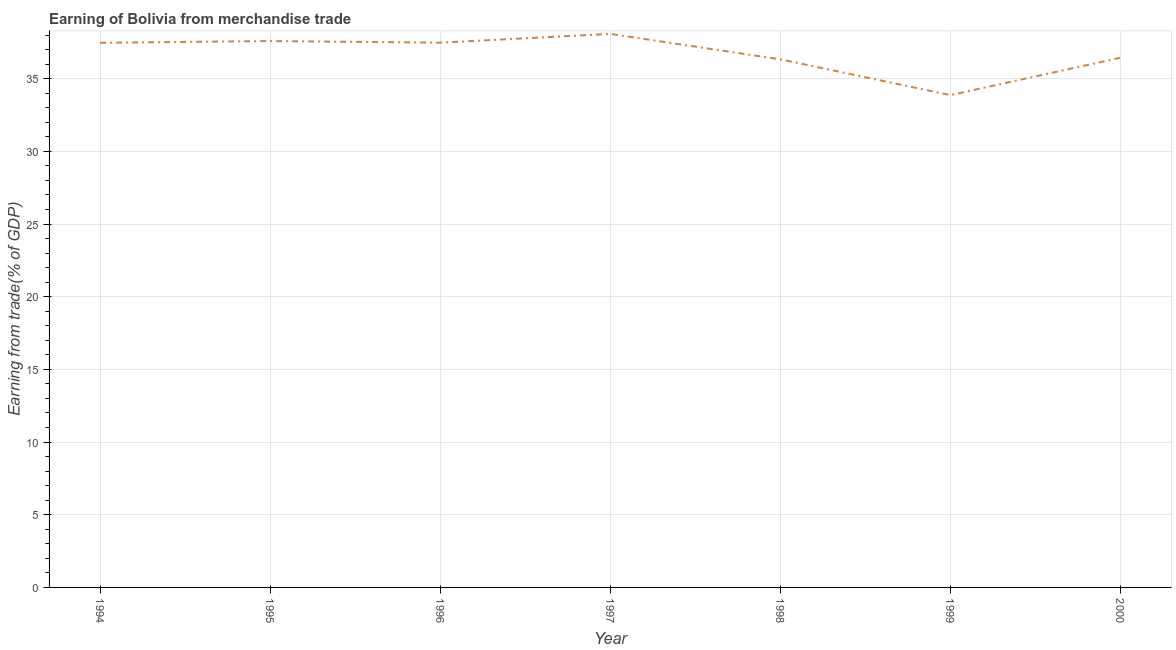What is the earning from merchandise trade in 1996?
Your answer should be very brief. 37.47. Across all years, what is the maximum earning from merchandise trade?
Your answer should be compact. 38.08. Across all years, what is the minimum earning from merchandise trade?
Provide a succinct answer. 33.87. In which year was the earning from merchandise trade maximum?
Your answer should be very brief. 1997. In which year was the earning from merchandise trade minimum?
Offer a terse response. 1999. What is the sum of the earning from merchandise trade?
Offer a terse response. 257.24. What is the difference between the earning from merchandise trade in 1995 and 1997?
Give a very brief answer. -0.49. What is the average earning from merchandise trade per year?
Your answer should be compact. 36.75. What is the median earning from merchandise trade?
Offer a terse response. 37.47. What is the ratio of the earning from merchandise trade in 1995 to that in 1996?
Your answer should be very brief. 1. Is the earning from merchandise trade in 1997 less than that in 2000?
Offer a very short reply. No. Is the difference between the earning from merchandise trade in 1994 and 1997 greater than the difference between any two years?
Offer a terse response. No. What is the difference between the highest and the second highest earning from merchandise trade?
Make the answer very short. 0.49. What is the difference between the highest and the lowest earning from merchandise trade?
Offer a terse response. 4.21. In how many years, is the earning from merchandise trade greater than the average earning from merchandise trade taken over all years?
Your answer should be very brief. 4. Does the graph contain grids?
Ensure brevity in your answer.  Yes. What is the title of the graph?
Your response must be concise. Earning of Bolivia from merchandise trade. What is the label or title of the X-axis?
Keep it short and to the point. Year. What is the label or title of the Y-axis?
Provide a succinct answer. Earning from trade(% of GDP). What is the Earning from trade(% of GDP) of 1994?
Your answer should be compact. 37.47. What is the Earning from trade(% of GDP) in 1995?
Make the answer very short. 37.59. What is the Earning from trade(% of GDP) of 1996?
Your answer should be very brief. 37.47. What is the Earning from trade(% of GDP) of 1997?
Give a very brief answer. 38.08. What is the Earning from trade(% of GDP) of 1998?
Your answer should be very brief. 36.33. What is the Earning from trade(% of GDP) of 1999?
Offer a very short reply. 33.87. What is the Earning from trade(% of GDP) in 2000?
Your response must be concise. 36.44. What is the difference between the Earning from trade(% of GDP) in 1994 and 1995?
Offer a terse response. -0.12. What is the difference between the Earning from trade(% of GDP) in 1994 and 1996?
Ensure brevity in your answer.  -0.01. What is the difference between the Earning from trade(% of GDP) in 1994 and 1997?
Offer a very short reply. -0.61. What is the difference between the Earning from trade(% of GDP) in 1994 and 1998?
Provide a succinct answer. 1.14. What is the difference between the Earning from trade(% of GDP) in 1994 and 1999?
Your response must be concise. 3.6. What is the difference between the Earning from trade(% of GDP) in 1994 and 2000?
Offer a very short reply. 1.03. What is the difference between the Earning from trade(% of GDP) in 1995 and 1996?
Your answer should be very brief. 0.11. What is the difference between the Earning from trade(% of GDP) in 1995 and 1997?
Your answer should be compact. -0.49. What is the difference between the Earning from trade(% of GDP) in 1995 and 1998?
Offer a very short reply. 1.26. What is the difference between the Earning from trade(% of GDP) in 1995 and 1999?
Offer a very short reply. 3.72. What is the difference between the Earning from trade(% of GDP) in 1995 and 2000?
Provide a succinct answer. 1.15. What is the difference between the Earning from trade(% of GDP) in 1996 and 1997?
Offer a terse response. -0.6. What is the difference between the Earning from trade(% of GDP) in 1996 and 1998?
Provide a succinct answer. 1.15. What is the difference between the Earning from trade(% of GDP) in 1996 and 1999?
Provide a short and direct response. 3.61. What is the difference between the Earning from trade(% of GDP) in 1996 and 2000?
Give a very brief answer. 1.04. What is the difference between the Earning from trade(% of GDP) in 1997 and 1998?
Give a very brief answer. 1.75. What is the difference between the Earning from trade(% of GDP) in 1997 and 1999?
Ensure brevity in your answer.  4.21. What is the difference between the Earning from trade(% of GDP) in 1997 and 2000?
Provide a succinct answer. 1.64. What is the difference between the Earning from trade(% of GDP) in 1998 and 1999?
Offer a terse response. 2.46. What is the difference between the Earning from trade(% of GDP) in 1998 and 2000?
Offer a terse response. -0.11. What is the difference between the Earning from trade(% of GDP) in 1999 and 2000?
Your answer should be compact. -2.57. What is the ratio of the Earning from trade(% of GDP) in 1994 to that in 1997?
Your response must be concise. 0.98. What is the ratio of the Earning from trade(% of GDP) in 1994 to that in 1998?
Your answer should be very brief. 1.03. What is the ratio of the Earning from trade(% of GDP) in 1994 to that in 1999?
Your response must be concise. 1.11. What is the ratio of the Earning from trade(% of GDP) in 1994 to that in 2000?
Ensure brevity in your answer.  1.03. What is the ratio of the Earning from trade(% of GDP) in 1995 to that in 1996?
Offer a terse response. 1. What is the ratio of the Earning from trade(% of GDP) in 1995 to that in 1997?
Offer a terse response. 0.99. What is the ratio of the Earning from trade(% of GDP) in 1995 to that in 1998?
Make the answer very short. 1.03. What is the ratio of the Earning from trade(% of GDP) in 1995 to that in 1999?
Your answer should be very brief. 1.11. What is the ratio of the Earning from trade(% of GDP) in 1995 to that in 2000?
Offer a terse response. 1.03. What is the ratio of the Earning from trade(% of GDP) in 1996 to that in 1998?
Keep it short and to the point. 1.03. What is the ratio of the Earning from trade(% of GDP) in 1996 to that in 1999?
Your answer should be very brief. 1.11. What is the ratio of the Earning from trade(% of GDP) in 1996 to that in 2000?
Offer a terse response. 1.03. What is the ratio of the Earning from trade(% of GDP) in 1997 to that in 1998?
Give a very brief answer. 1.05. What is the ratio of the Earning from trade(% of GDP) in 1997 to that in 1999?
Your response must be concise. 1.12. What is the ratio of the Earning from trade(% of GDP) in 1997 to that in 2000?
Offer a very short reply. 1.04. What is the ratio of the Earning from trade(% of GDP) in 1998 to that in 1999?
Keep it short and to the point. 1.07. What is the ratio of the Earning from trade(% of GDP) in 1998 to that in 2000?
Your answer should be very brief. 1. What is the ratio of the Earning from trade(% of GDP) in 1999 to that in 2000?
Keep it short and to the point. 0.93. 